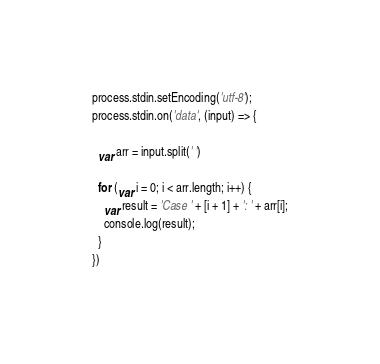Convert code to text. <code><loc_0><loc_0><loc_500><loc_500><_JavaScript_>process.stdin.setEncoding('utf-8');
process.stdin.on('data', (input) => {

  var arr = input.split(' ')

  for (var i = 0; i < arr.length; i++) {
    var result = 'Case ' + [i + 1] + ': ' + arr[i];
    console.log(result);
  }
})
</code> 